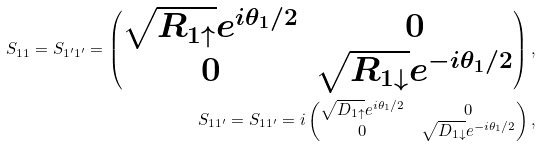<formula> <loc_0><loc_0><loc_500><loc_500>S _ { 1 1 } = S _ { 1 ^ { \prime } 1 ^ { \prime } } = \begin{pmatrix} \sqrt { R _ { 1 \uparrow } } e ^ { i \theta _ { 1 } / 2 } & 0 \\ 0 & \sqrt { R _ { 1 \downarrow } } e ^ { - i \theta _ { 1 } / 2 } \\ \end{pmatrix} , \\ S _ { 1 1 ^ { \prime } } = S _ { 1 1 ^ { \prime } } = i \begin{pmatrix} \sqrt { D _ { 1 \uparrow } } e ^ { i \theta _ { 1 } / 2 } & 0 \\ 0 & \sqrt { D _ { 1 \downarrow } } e ^ { - i \theta _ { 1 } / 2 } \\ \end{pmatrix} ,</formula> 